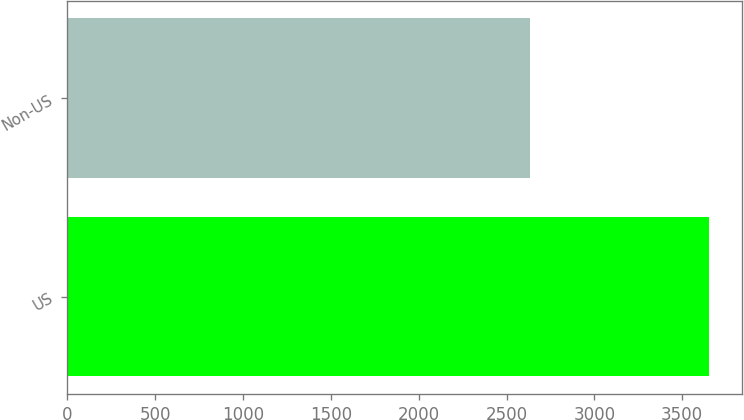Convert chart to OTSL. <chart><loc_0><loc_0><loc_500><loc_500><bar_chart><fcel>US<fcel>Non-US<nl><fcel>3655<fcel>2634<nl></chart> 